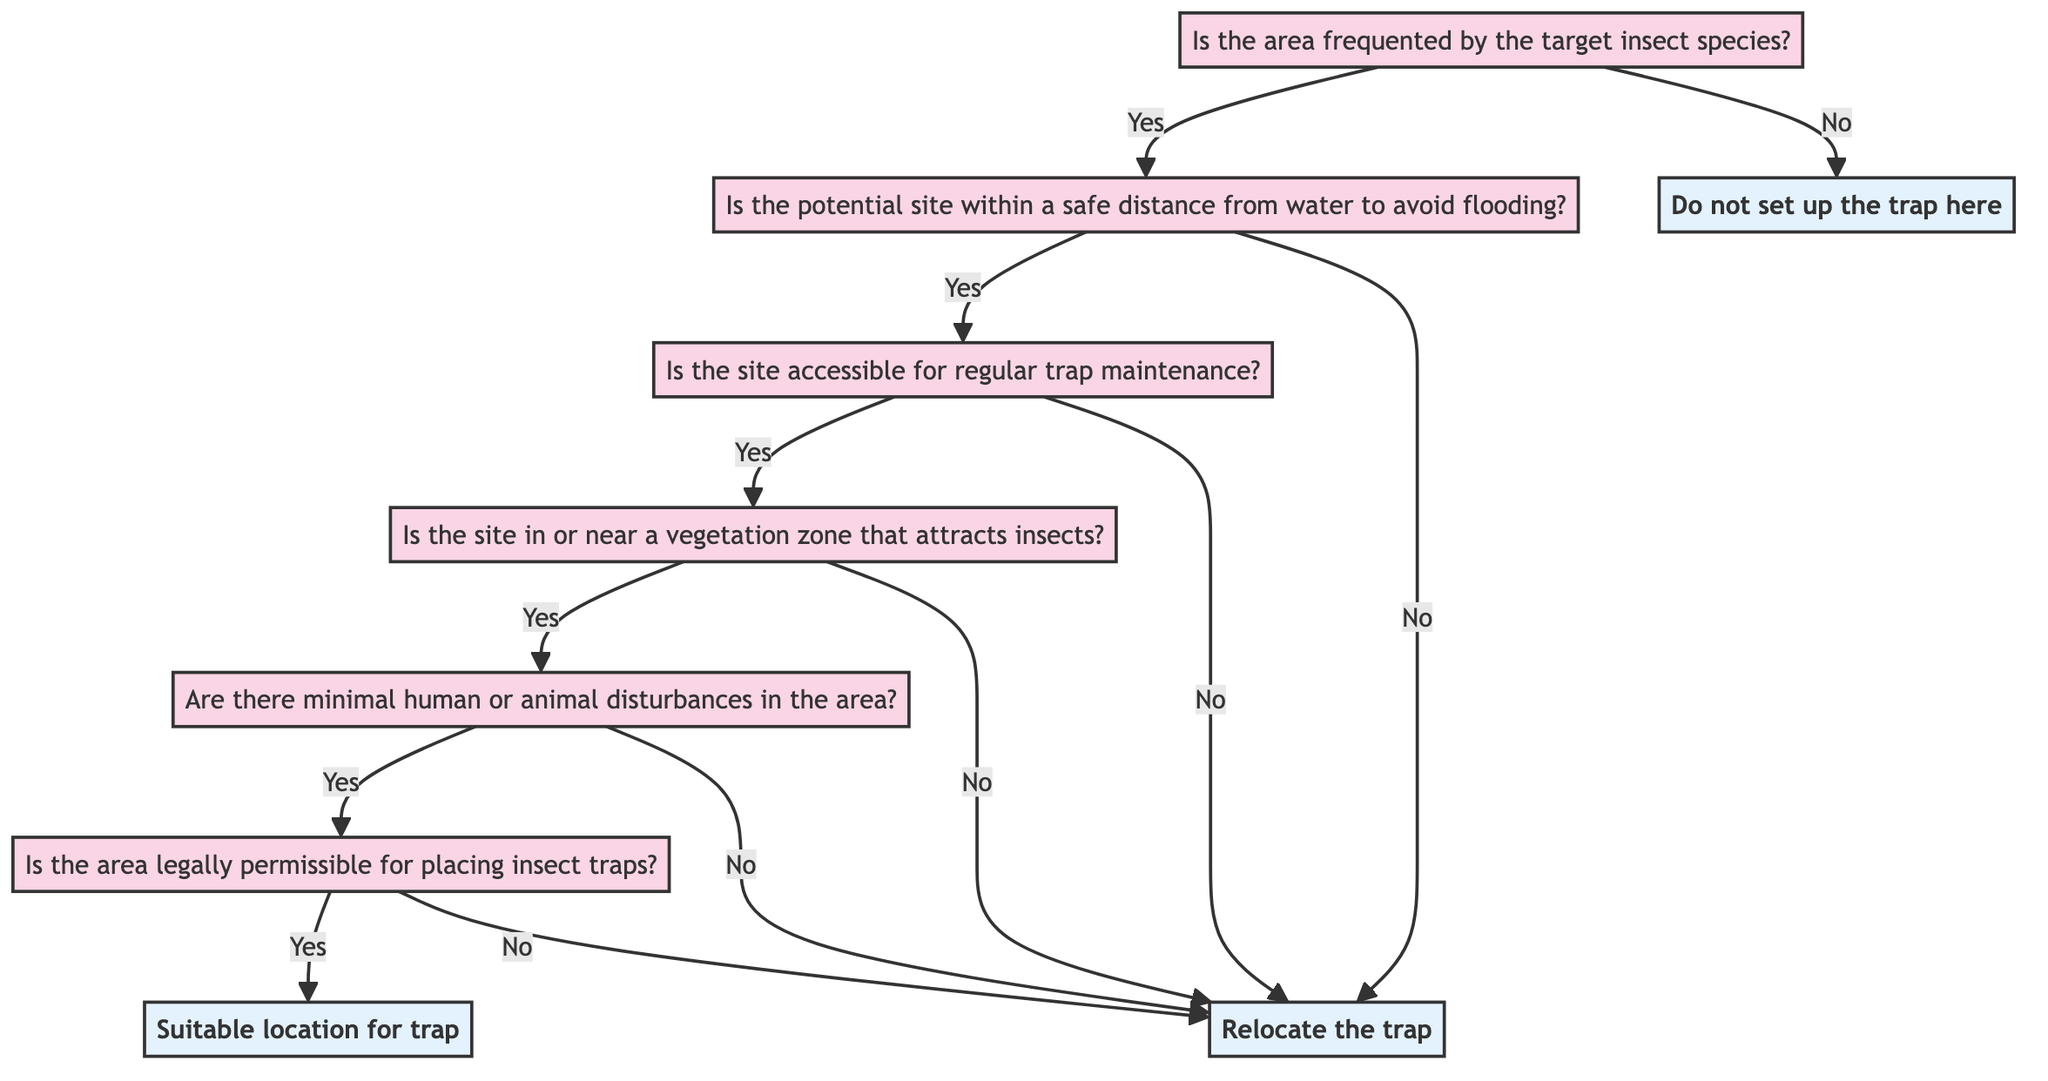What is the first question in the decision tree? The first question displayed in the decision tree is presented at node 1, which asks, "Is the area frequented by the target insect species?"
Answer: Is the area frequented by the target insect species? How many endpoints are in the decision tree? The decision tree contains three endpoints: one for when the area is not frequented by the target insect species, one for when the trap should be relocated, and one for a suitable location. Therefore, there are three endpoints.
Answer: 3 What is the outcome if the answer to the second question is "No"? Starting from question node 2, if the answer is "No," the flow moves to endpoint E2, which states, "Relocate the trap to a more suitable location."
Answer: Relocate the trap to a more suitable location What happens if the answer to question five is "No"? If the answer to question five is "No," the flow directs you to endpoint E2, indicating that you should relocate the trap to a more suitable location.
Answer: Relocate the trap to a more suitable location What node comes after answering "Yes" to question four? If the answer to question four is "Yes," you proceed to question node 5, which asks, "Are there minimal human or animal disturbances in the area?" This follows the logical path of the decision tree.
Answer: 5 If the area is not legally permissible for placing insect traps, what is the output? If the answer to question six is "No," the flow directs to endpoint E2, which states, "Relocate the trap to a more suitable location." This indicates that legal restrictions prevent setting up traps in the area.
Answer: Relocate the trap to a more suitable location What condition must be met after questions one and two to determine if the trap location is suitable? After answering "Yes" in both questions one and two, the subsequent conditions regarding accessibility and vegetation zones must also be met to decide on the suitability of the trap location.
Answer: All conditions must be met How does the flow proceed from question three if the answer is "Yes"? If question three is answered "Yes," the flow continues to question four, indicating that the site is accessible for regular trap maintenance and leading to the next evaluation of the vegetation zone.
Answer: 4 